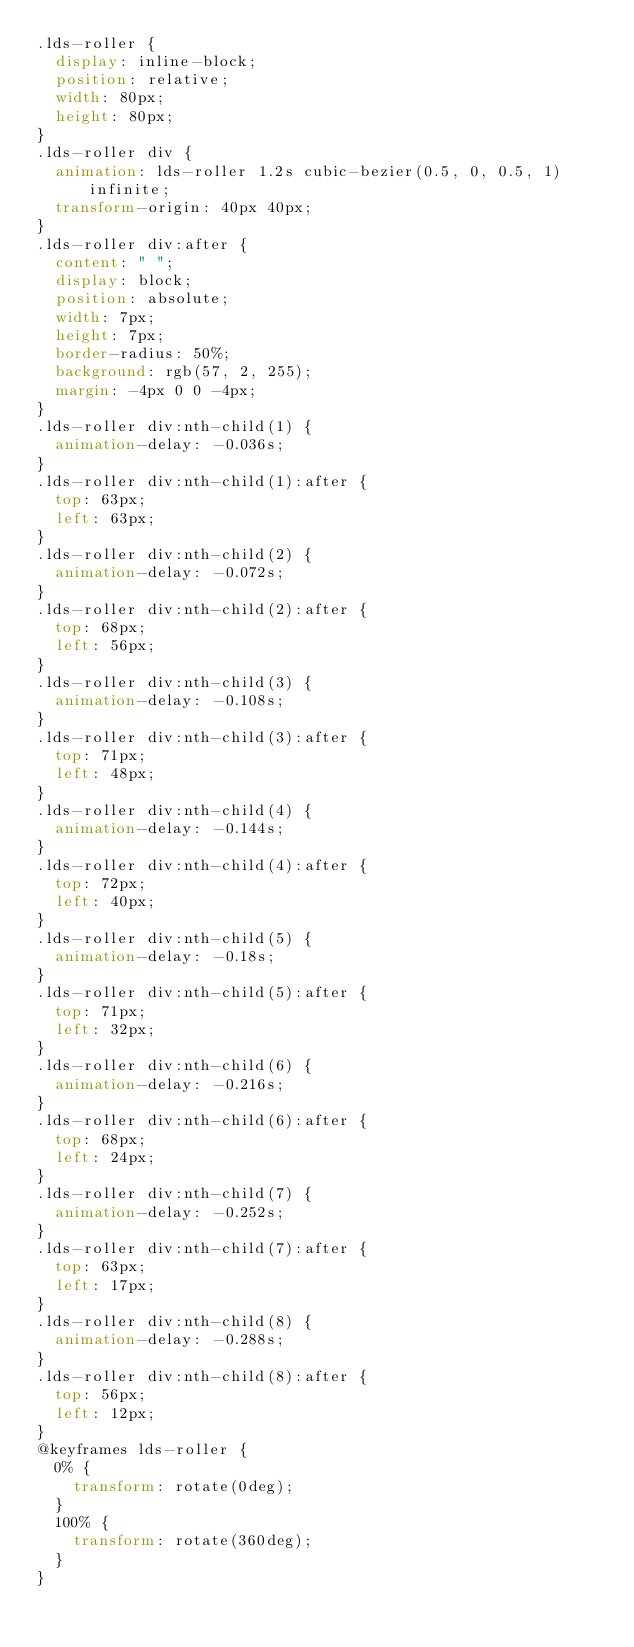Convert code to text. <code><loc_0><loc_0><loc_500><loc_500><_CSS_>.lds-roller {
  display: inline-block;
  position: relative;
  width: 80px;
  height: 80px;
}
.lds-roller div {
  animation: lds-roller 1.2s cubic-bezier(0.5, 0, 0.5, 1) infinite;
  transform-origin: 40px 40px;
}
.lds-roller div:after {
  content: " ";
  display: block;
  position: absolute;
  width: 7px;
  height: 7px;
  border-radius: 50%;
  background: rgb(57, 2, 255);
  margin: -4px 0 0 -4px;
}
.lds-roller div:nth-child(1) {
  animation-delay: -0.036s;
}
.lds-roller div:nth-child(1):after {
  top: 63px;
  left: 63px;
}
.lds-roller div:nth-child(2) {
  animation-delay: -0.072s;
}
.lds-roller div:nth-child(2):after {
  top: 68px;
  left: 56px;
}
.lds-roller div:nth-child(3) {
  animation-delay: -0.108s;
}
.lds-roller div:nth-child(3):after {
  top: 71px;
  left: 48px;
}
.lds-roller div:nth-child(4) {
  animation-delay: -0.144s;
}
.lds-roller div:nth-child(4):after {
  top: 72px;
  left: 40px;
}
.lds-roller div:nth-child(5) {
  animation-delay: -0.18s;
}
.lds-roller div:nth-child(5):after {
  top: 71px;
  left: 32px;
}
.lds-roller div:nth-child(6) {
  animation-delay: -0.216s;
}
.lds-roller div:nth-child(6):after {
  top: 68px;
  left: 24px;
}
.lds-roller div:nth-child(7) {
  animation-delay: -0.252s;
}
.lds-roller div:nth-child(7):after {
  top: 63px;
  left: 17px;
}
.lds-roller div:nth-child(8) {
  animation-delay: -0.288s;
}
.lds-roller div:nth-child(8):after {
  top: 56px;
  left: 12px;
}
@keyframes lds-roller {
  0% {
    transform: rotate(0deg);
  }
  100% {
    transform: rotate(360deg);
  }
}
</code> 